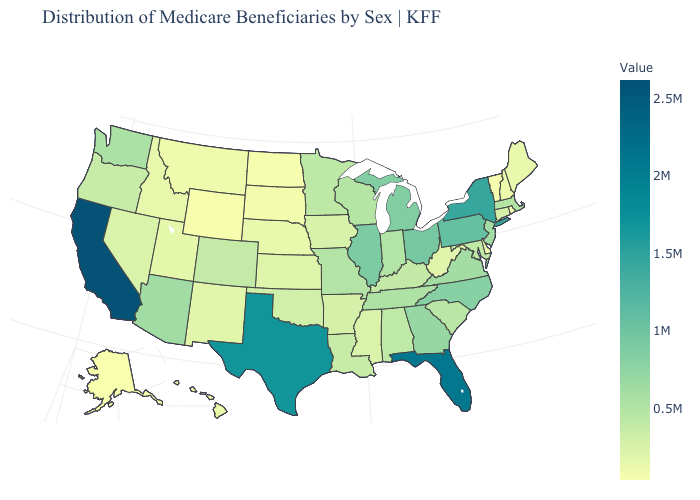Which states have the highest value in the USA?
Concise answer only. California. Does California have the highest value in the USA?
Short answer required. Yes. Which states have the lowest value in the South?
Write a very short answer. Delaware. Which states have the lowest value in the Northeast?
Concise answer only. Vermont. Does Minnesota have the highest value in the MidWest?
Write a very short answer. No. Is the legend a continuous bar?
Concise answer only. Yes. 